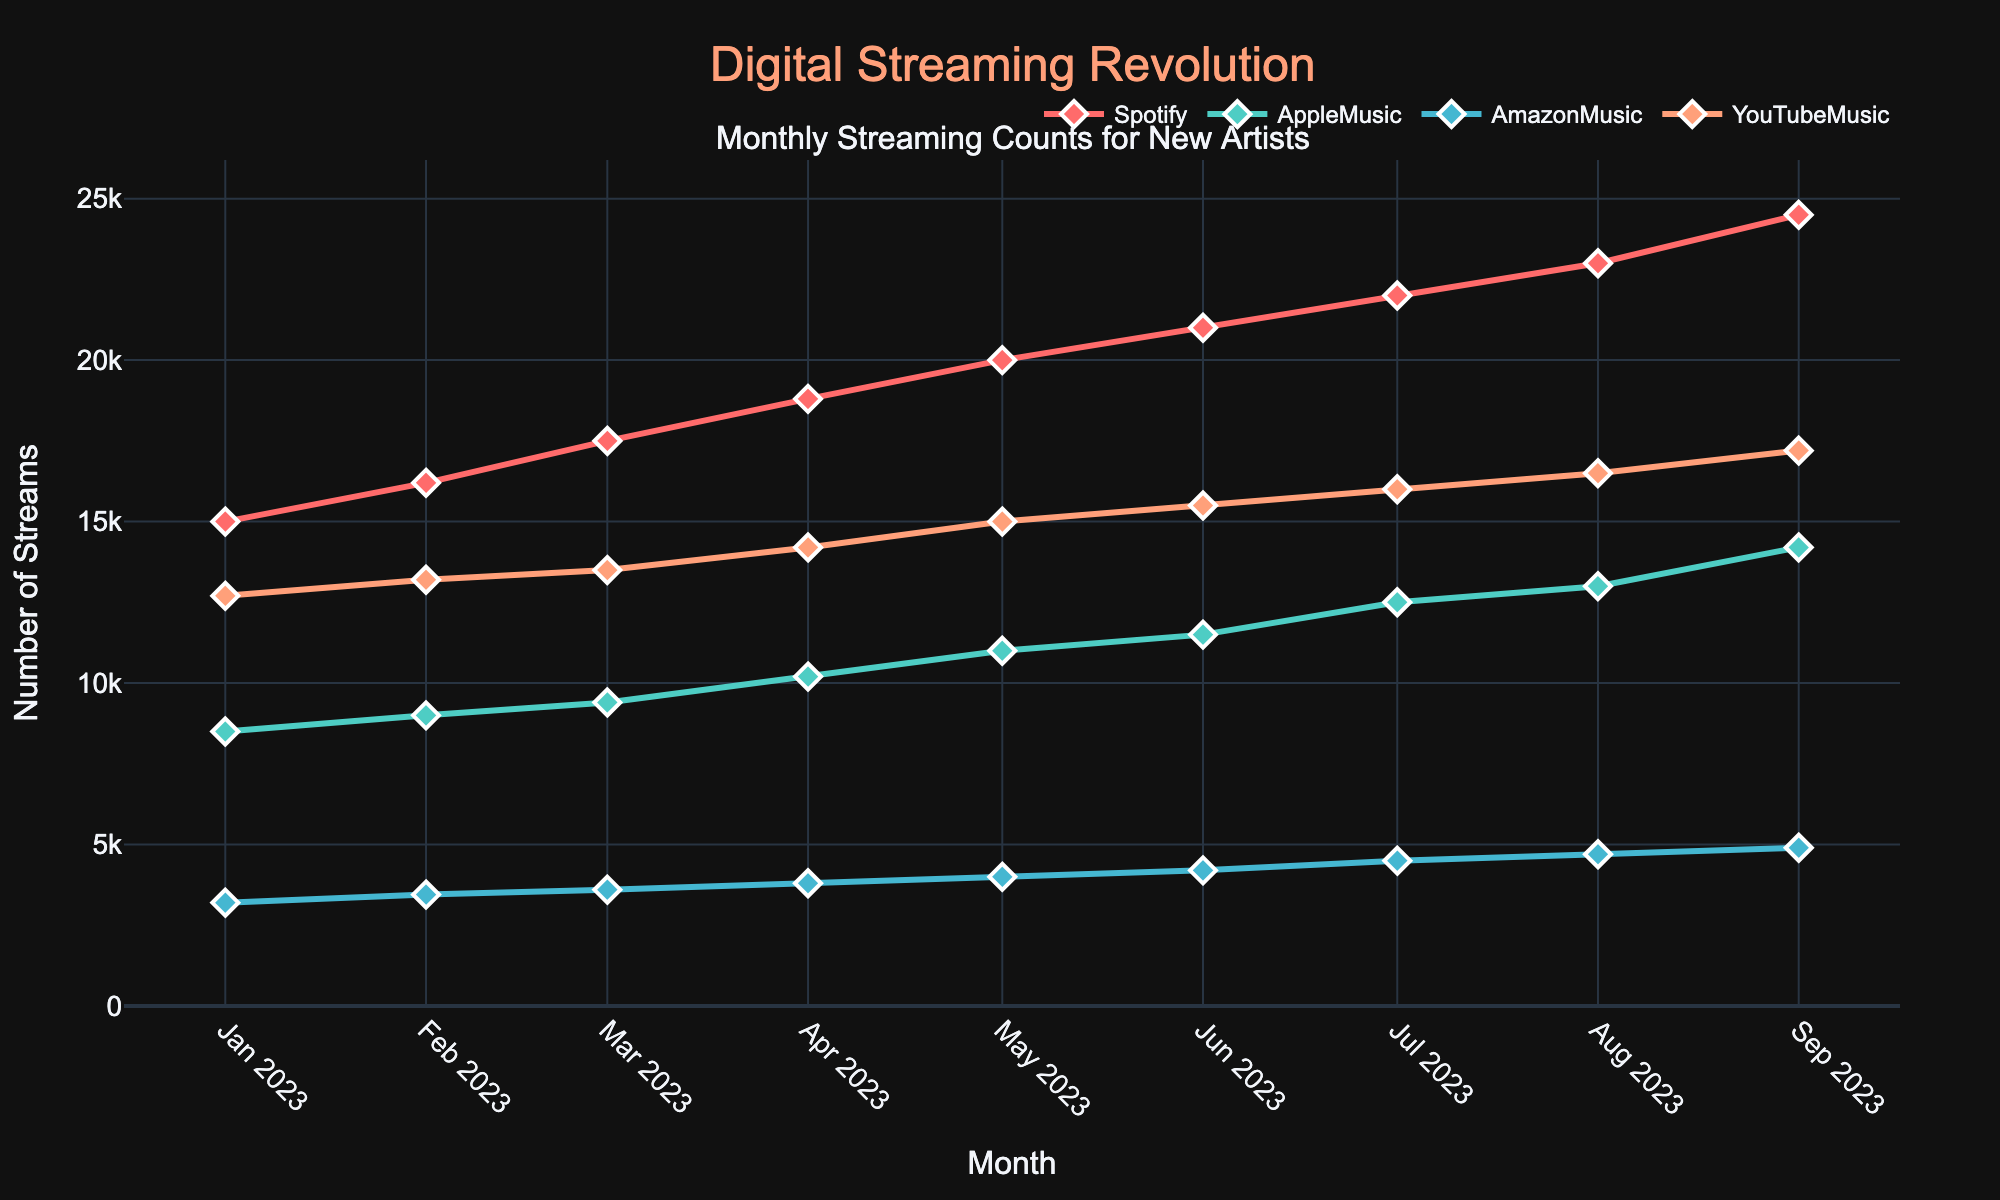What is the title of the plot? The title of the plot is found at the top of the figure. It reads "Monthly Streaming Counts for New Artists".
Answer: Monthly Streaming Counts for New Artists Which platform shows the highest streaming count in July 2023? To find this, look at the data points for July 2023 across all the platforms (Spotify, AppleMusic, AmazonMusic, YouTubeMusic). The highest value is with Spotify, which has 22,000 streams.
Answer: Spotify Which platform had the lowest number of streams in January 2023? To answer this, look at the streaming counts for each platform in January 2023. AmazonMusic has the lowest count with 3,200 streams.
Answer: AmazonMusic What is the average number of streams on Spotify across all months? To find the average number of streams on Spotify, sum all the monthly streaming counts and divide by the number of months. (15000+16200+17500+18800+20000+21000+22000+23000+24500) / 9 = 20,000.
Answer: 20,000 How does the number of YouTubeMusic streams in September 2023 compare with the number in April 2023? Look at the streaming counts for YouTubeMusic in both September 2023 and April 2023. In April, it is 14,200, and in September, it is 17,200. September has 3,000 more streams than April.
Answer: 3,000 more streams What is the total number of streams on AmazonMusic from January to September 2023? Sum the monthly streaming counts from January to September 2023 for AmazonMusic. (3200 + 3450 + 3600 + 3800 + 4000 + 4200 + 4500 + 4700 + 4900) = 36,350.
Answer: 36,350 Which month shows the largest increase in streams for AppleMusic compared to the previous month? Calculate the increase month-over-month for AppleMusic. The largest increase is from August (13,000) to September (14,200), with a difference of 1,200.
Answer: Between August and September What color is used to represent YouTubeMusic in the plot? Look at the colors of the lines represented in the plot. YouTubeMusic is represented in a salmon-like color.
Answer: Salmon What is the trend in the number of Spotify streams from January to September 2023? Observe the line representing Spotify streams from January to September 2023. There is a consistently upward trend with an increasing number of streams each month.
Answer: Upward trend Which platform has the most consistent increase in streaming numbers over the months? Compare the monthly increases for all platforms. Spotify shows a consistent and steady increase each month.
Answer: Spotify 